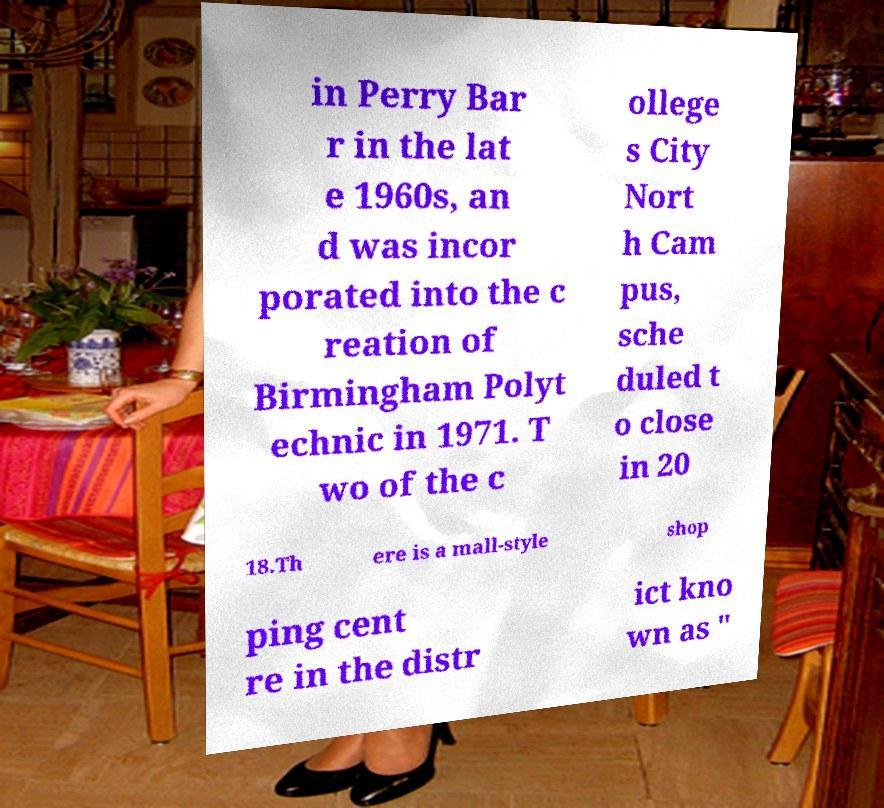What messages or text are displayed in this image? I need them in a readable, typed format. in Perry Bar r in the lat e 1960s, an d was incor porated into the c reation of Birmingham Polyt echnic in 1971. T wo of the c ollege s City Nort h Cam pus, sche duled t o close in 20 18.Th ere is a mall-style shop ping cent re in the distr ict kno wn as " 